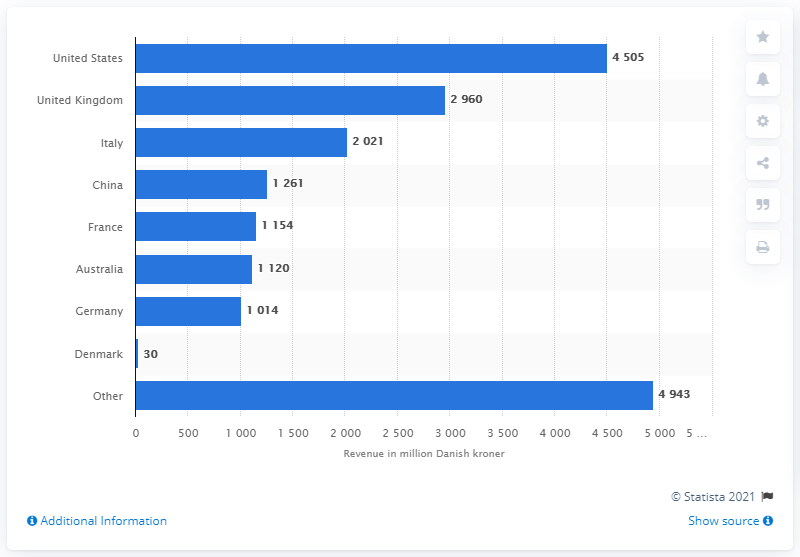Indicate a few pertinent items in this graphic. The sum of the values of Italy and the United Kingdom is greater than that of the United States. China is the country with the highest revenue, at 1261. Pandora A/S generated approximately 4,505 U.S. dollars in the United States in 2020. 